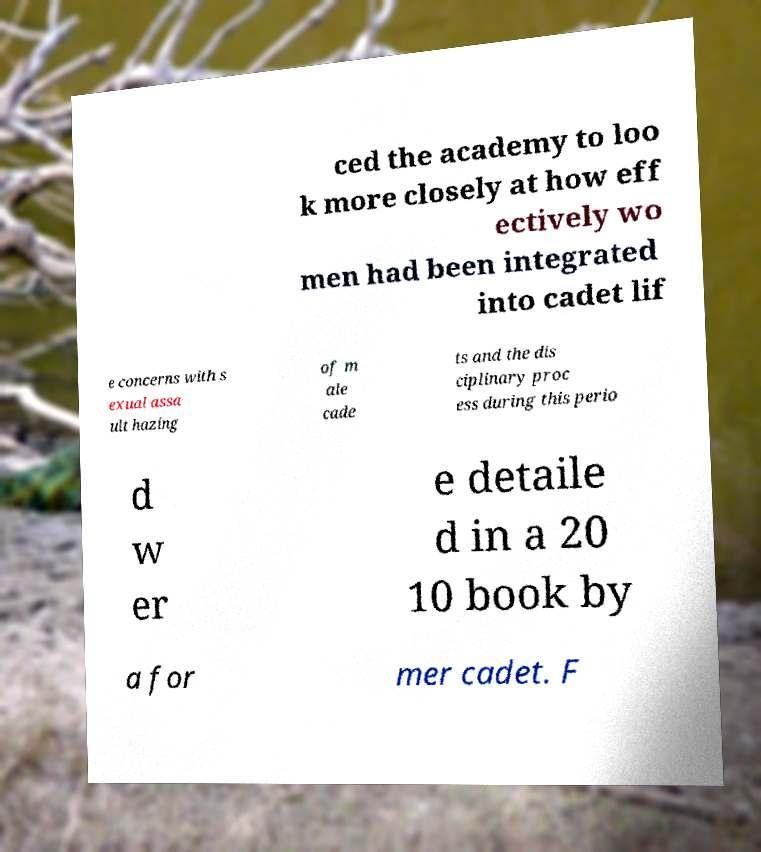What messages or text are displayed in this image? I need them in a readable, typed format. ced the academy to loo k more closely at how eff ectively wo men had been integrated into cadet lif e concerns with s exual assa ult hazing of m ale cade ts and the dis ciplinary proc ess during this perio d w er e detaile d in a 20 10 book by a for mer cadet. F 